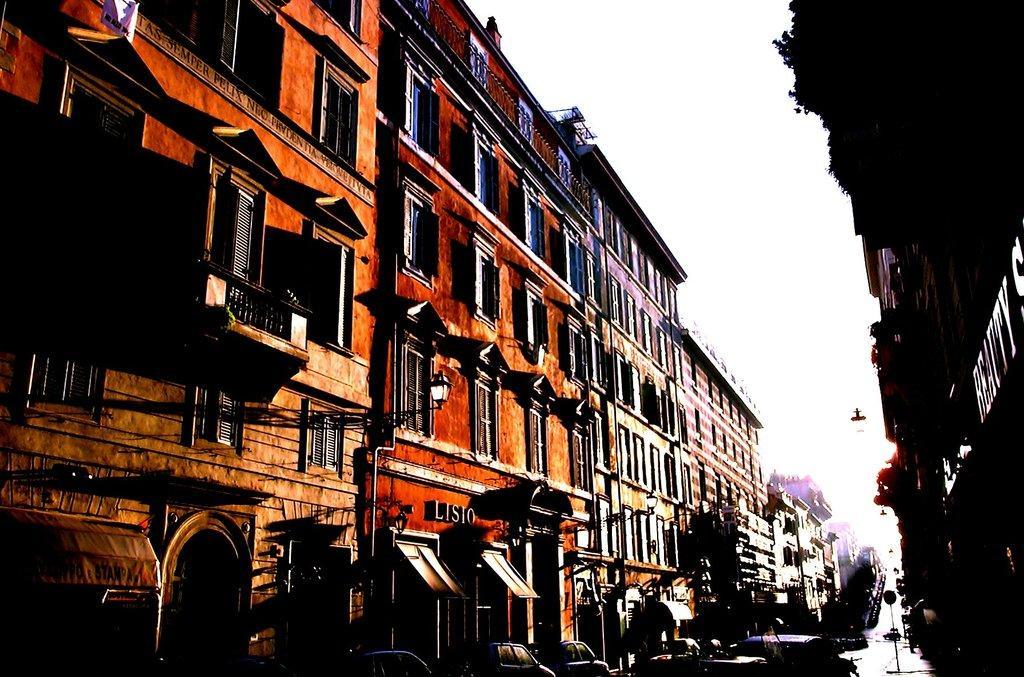Describe this image in one or two sentences. In this image there are buildings. At the bottom we can see cars. In the background there is sky. 